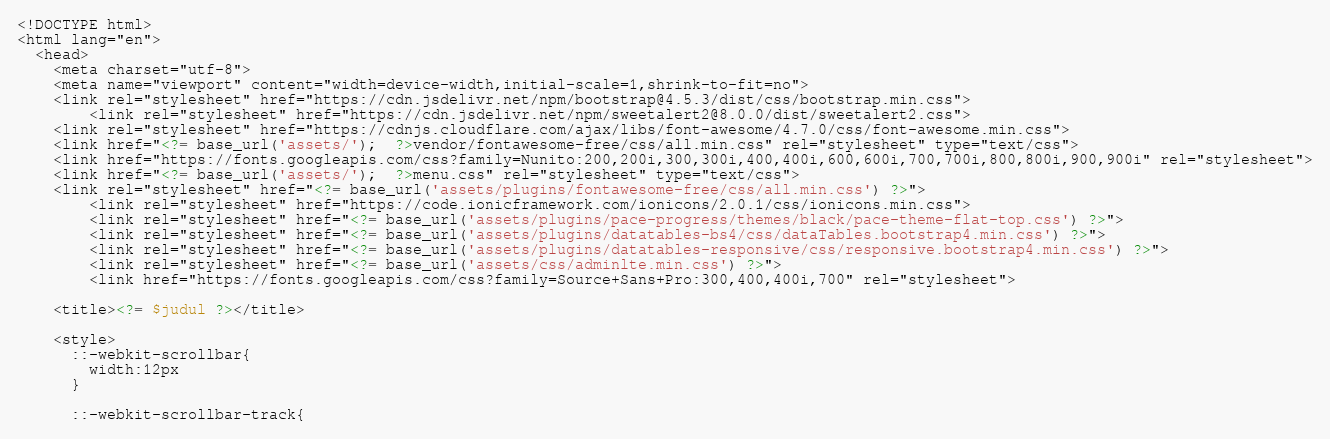<code> <loc_0><loc_0><loc_500><loc_500><_PHP_><!DOCTYPE html>
<html lang="en">
  <head>
    <meta charset="utf-8">
    <meta name="viewport" content="width=device-width,initial-scale=1,shrink-to-fit=no">
    <link rel="stylesheet" href="https://cdn.jsdelivr.net/npm/bootstrap@4.5.3/dist/css/bootstrap.min.css">
		<link rel="stylesheet" href="https://cdn.jsdelivr.net/npm/sweetalert2@8.0.0/dist/sweetalert2.css">
    <link rel="stylesheet" href="https://cdnjs.cloudflare.com/ajax/libs/font-awesome/4.7.0/css/font-awesome.min.css">
    <link href="<?= base_url('assets/');  ?>vendor/fontawesome-free/css/all.min.css" rel="stylesheet" type="text/css">
    <link href="https://fonts.googleapis.com/css?family=Nunito:200,200i,300,300i,400,400i,600,600i,700,700i,800,800i,900,900i" rel="stylesheet">
    <link href="<?= base_url('assets/');  ?>menu.css" rel="stylesheet" type="text/css">
    <link rel="stylesheet" href="<?= base_url('assets/plugins/fontawesome-free/css/all.min.css') ?>">
		<link rel="stylesheet" href="https://code.ionicframework.com/ionicons/2.0.1/css/ionicons.min.css">
		<link rel="stylesheet" href="<?= base_url('assets/plugins/pace-progress/themes/black/pace-theme-flat-top.css') ?>">
		<link rel="stylesheet" href="<?= base_url('assets/plugins/datatables-bs4/css/dataTables.bootstrap4.min.css') ?>">
		<link rel="stylesheet" href="<?= base_url('assets/plugins/datatables-responsive/css/responsive.bootstrap4.min.css') ?>">
		<link rel="stylesheet" href="<?= base_url('assets/css/adminlte.min.css') ?>">
		<link href="https://fonts.googleapis.com/css?family=Source+Sans+Pro:300,400,400i,700" rel="stylesheet">

    <title><?= $judul ?></title>

    <style>
      ::-webkit-scrollbar{
        width:12px
      }

      ::-webkit-scrollbar-track{</code> 